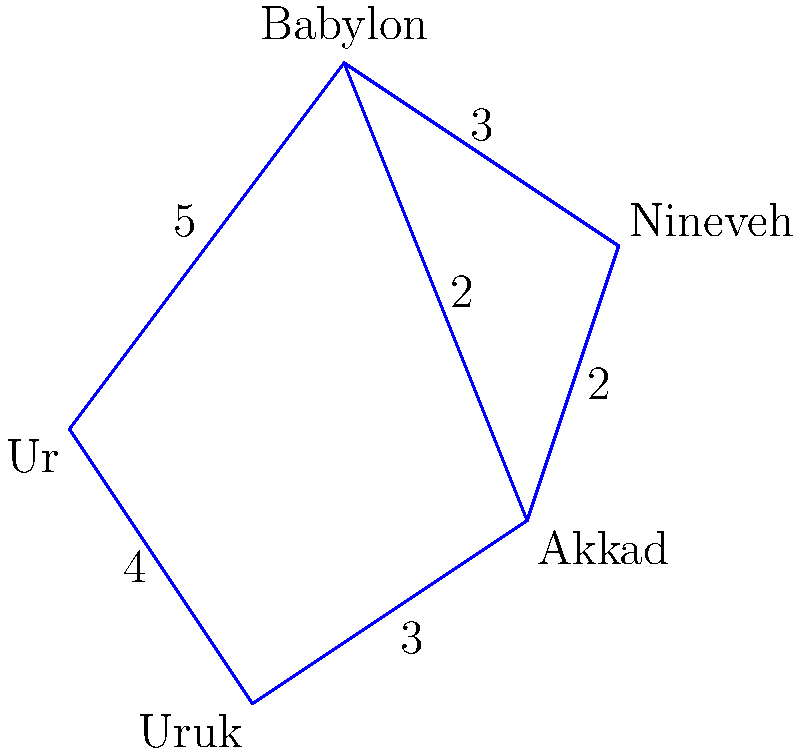In your research on ancient Mesopotamian trade routes, you've uncovered a map showing the distances between key cities. If a merchant wants to travel from Ur to Nineveh using the shortest possible path, what is the total distance they would need to cover? Assume that travel is only possible along the routes shown. To find the shortest path from Ur to Nineveh, we need to consider all possible routes and calculate their total distances. Let's break this down step-by-step:

1) Possible routes from Ur to Nineveh:
   a) Ur -> Babylon -> Nineveh
   b) Ur -> Uruk -> Akkad -> Nineveh
   c) Ur -> Uruk -> Akkad -> Babylon -> Nineveh
   d) Ur -> Babylon -> Akkad -> Nineveh

2) Calculate the distance for each route:
   a) Ur -> Babylon -> Nineveh:
      Distance = 5 + 3 = 8

   b) Ur -> Uruk -> Akkad -> Nineveh:
      Distance = 4 + 3 + 2 = 9

   c) Ur -> Uruk -> Akkad -> Babylon -> Nineveh:
      Distance = 4 + 3 + 2 + 3 = 12

   d) Ur -> Babylon -> Akkad -> Nineveh:
      Distance = 5 + 2 + 2 = 9

3) Compare the distances:
   Route (a): 8
   Route (b): 9
   Route (c): 12
   Route (d): 9

4) The shortest path is route (a): Ur -> Babylon -> Nineveh, with a total distance of 8.
Answer: 8 